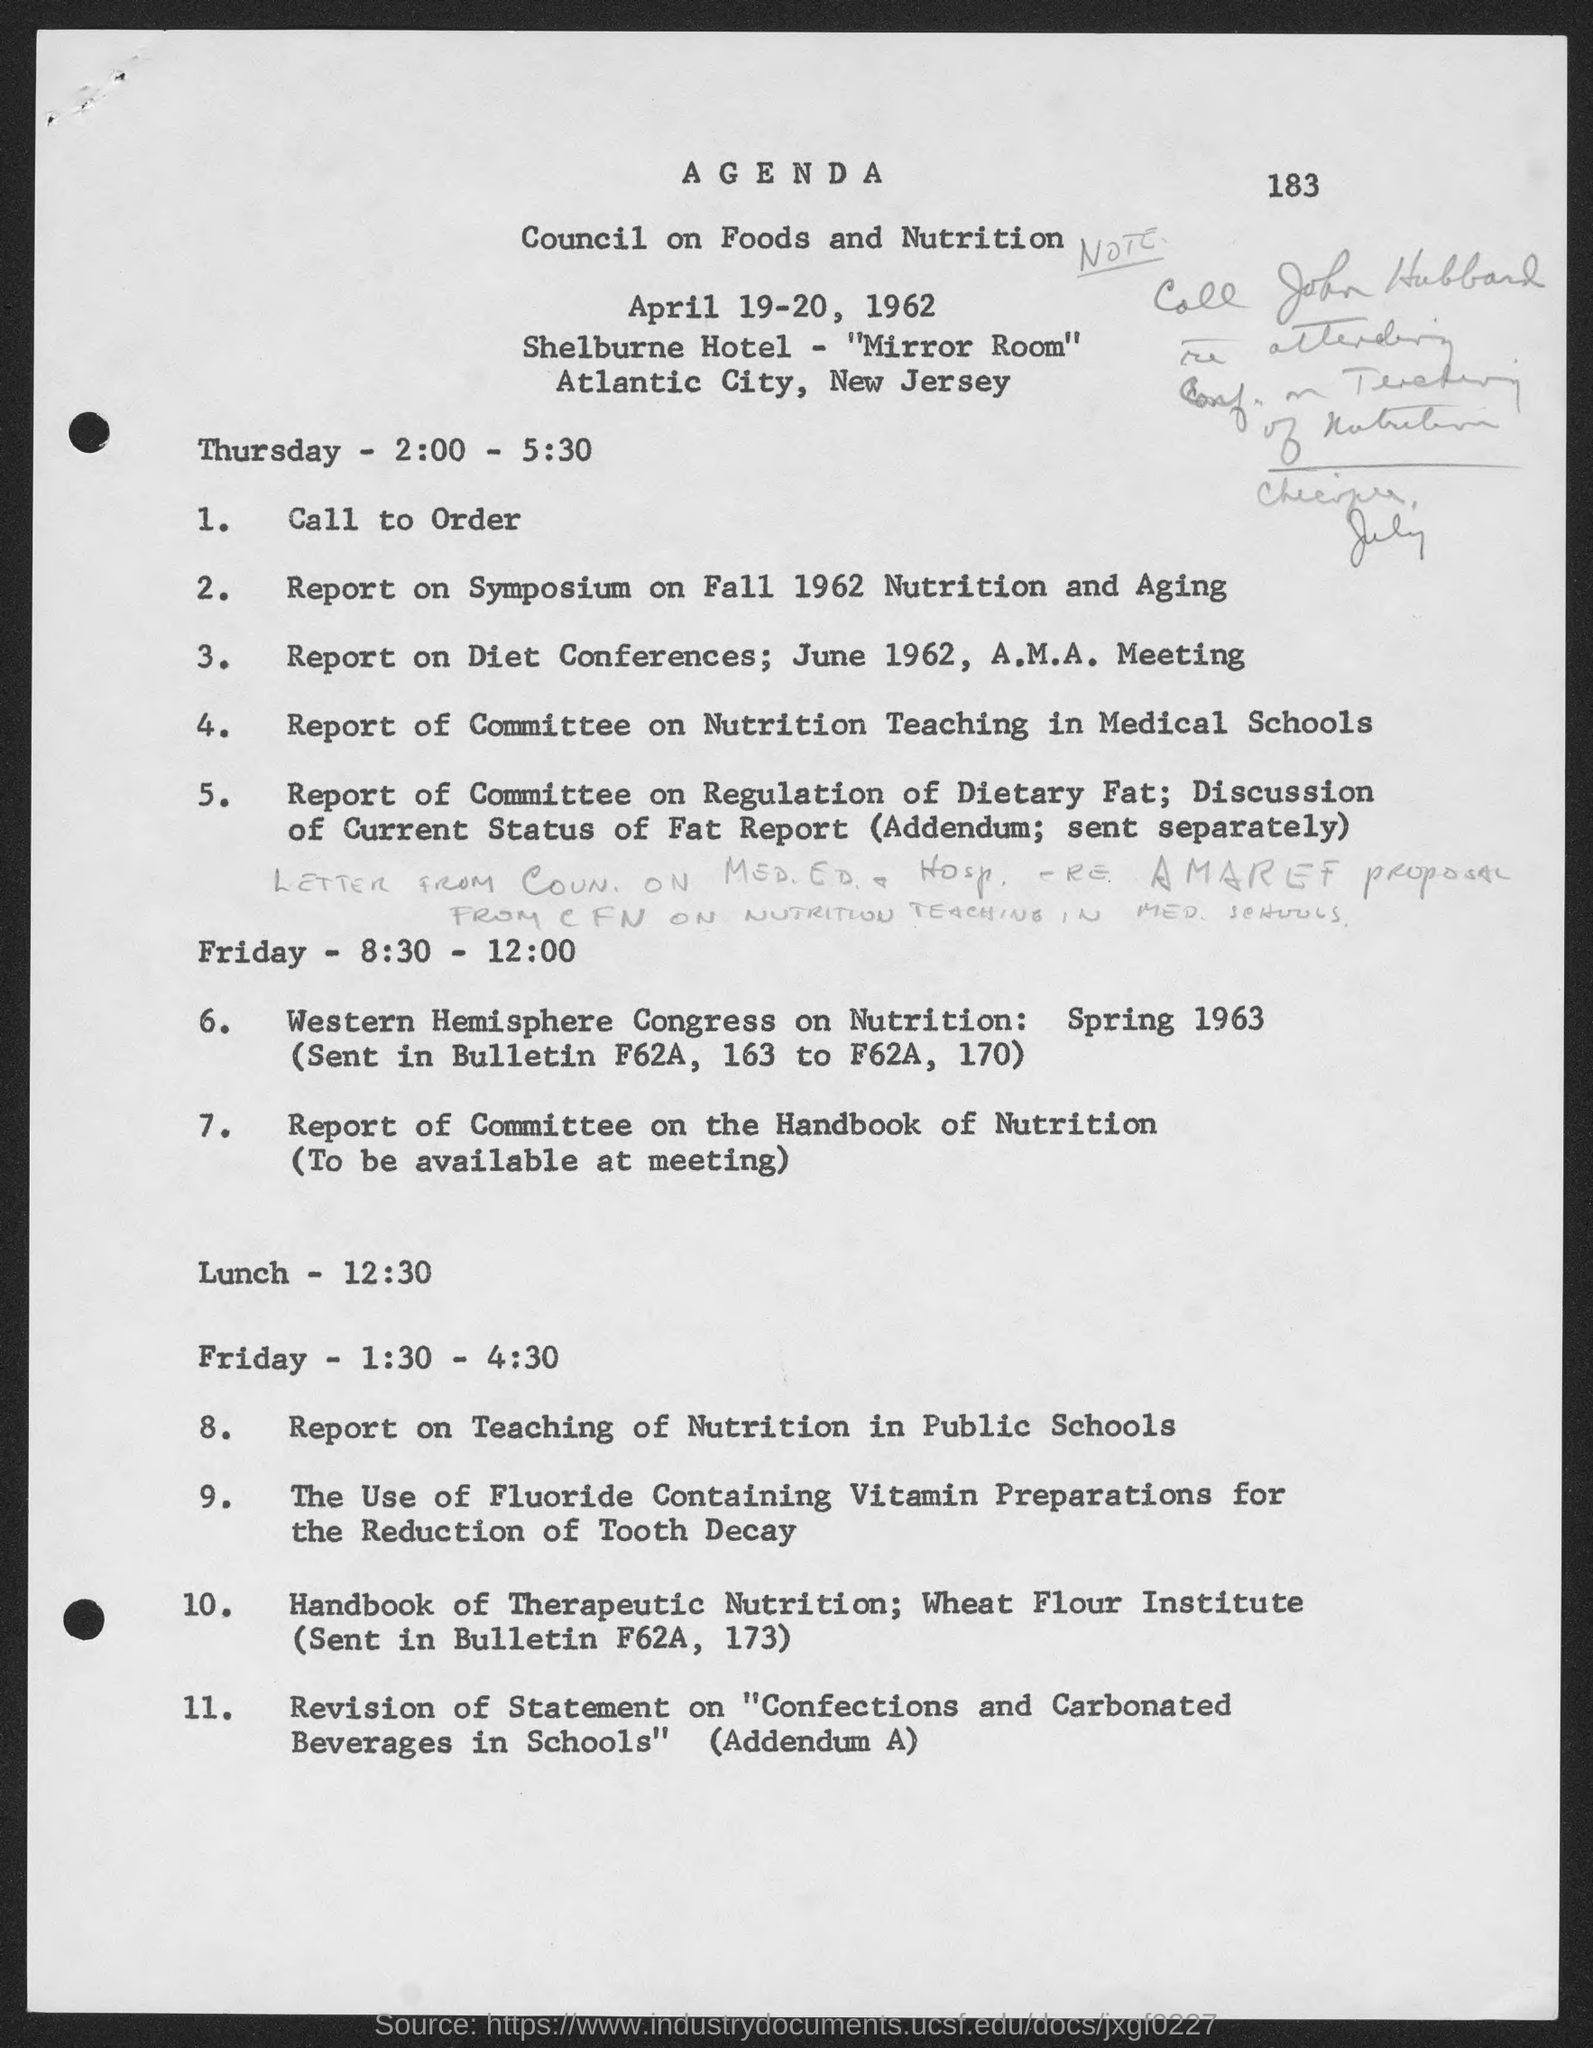Draw attention to some important aspects in this diagram. The Shelburne Hotel is hosting the event in the "Mirror Room". The lunch is scheduled for 12:30. The Council will take place on April 19-20, 1962. Atlantic City, New Jersey is the location. 